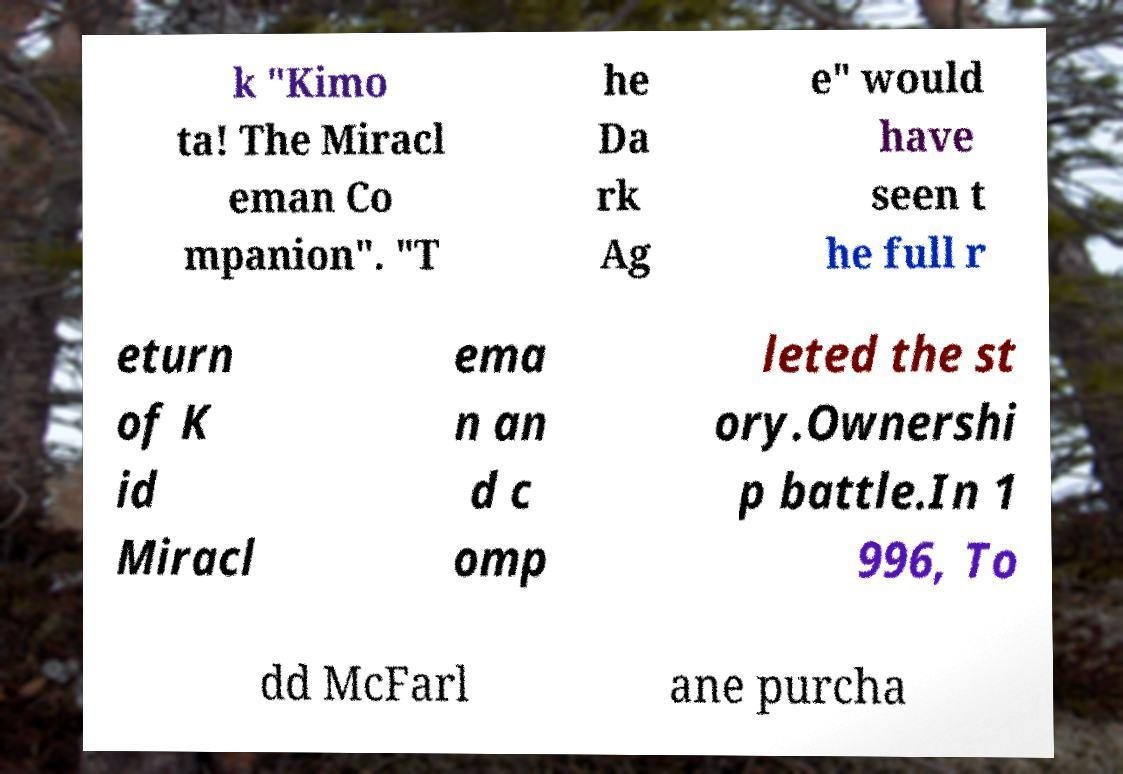There's text embedded in this image that I need extracted. Can you transcribe it verbatim? k "Kimo ta! The Miracl eman Co mpanion". "T he Da rk Ag e" would have seen t he full r eturn of K id Miracl ema n an d c omp leted the st ory.Ownershi p battle.In 1 996, To dd McFarl ane purcha 